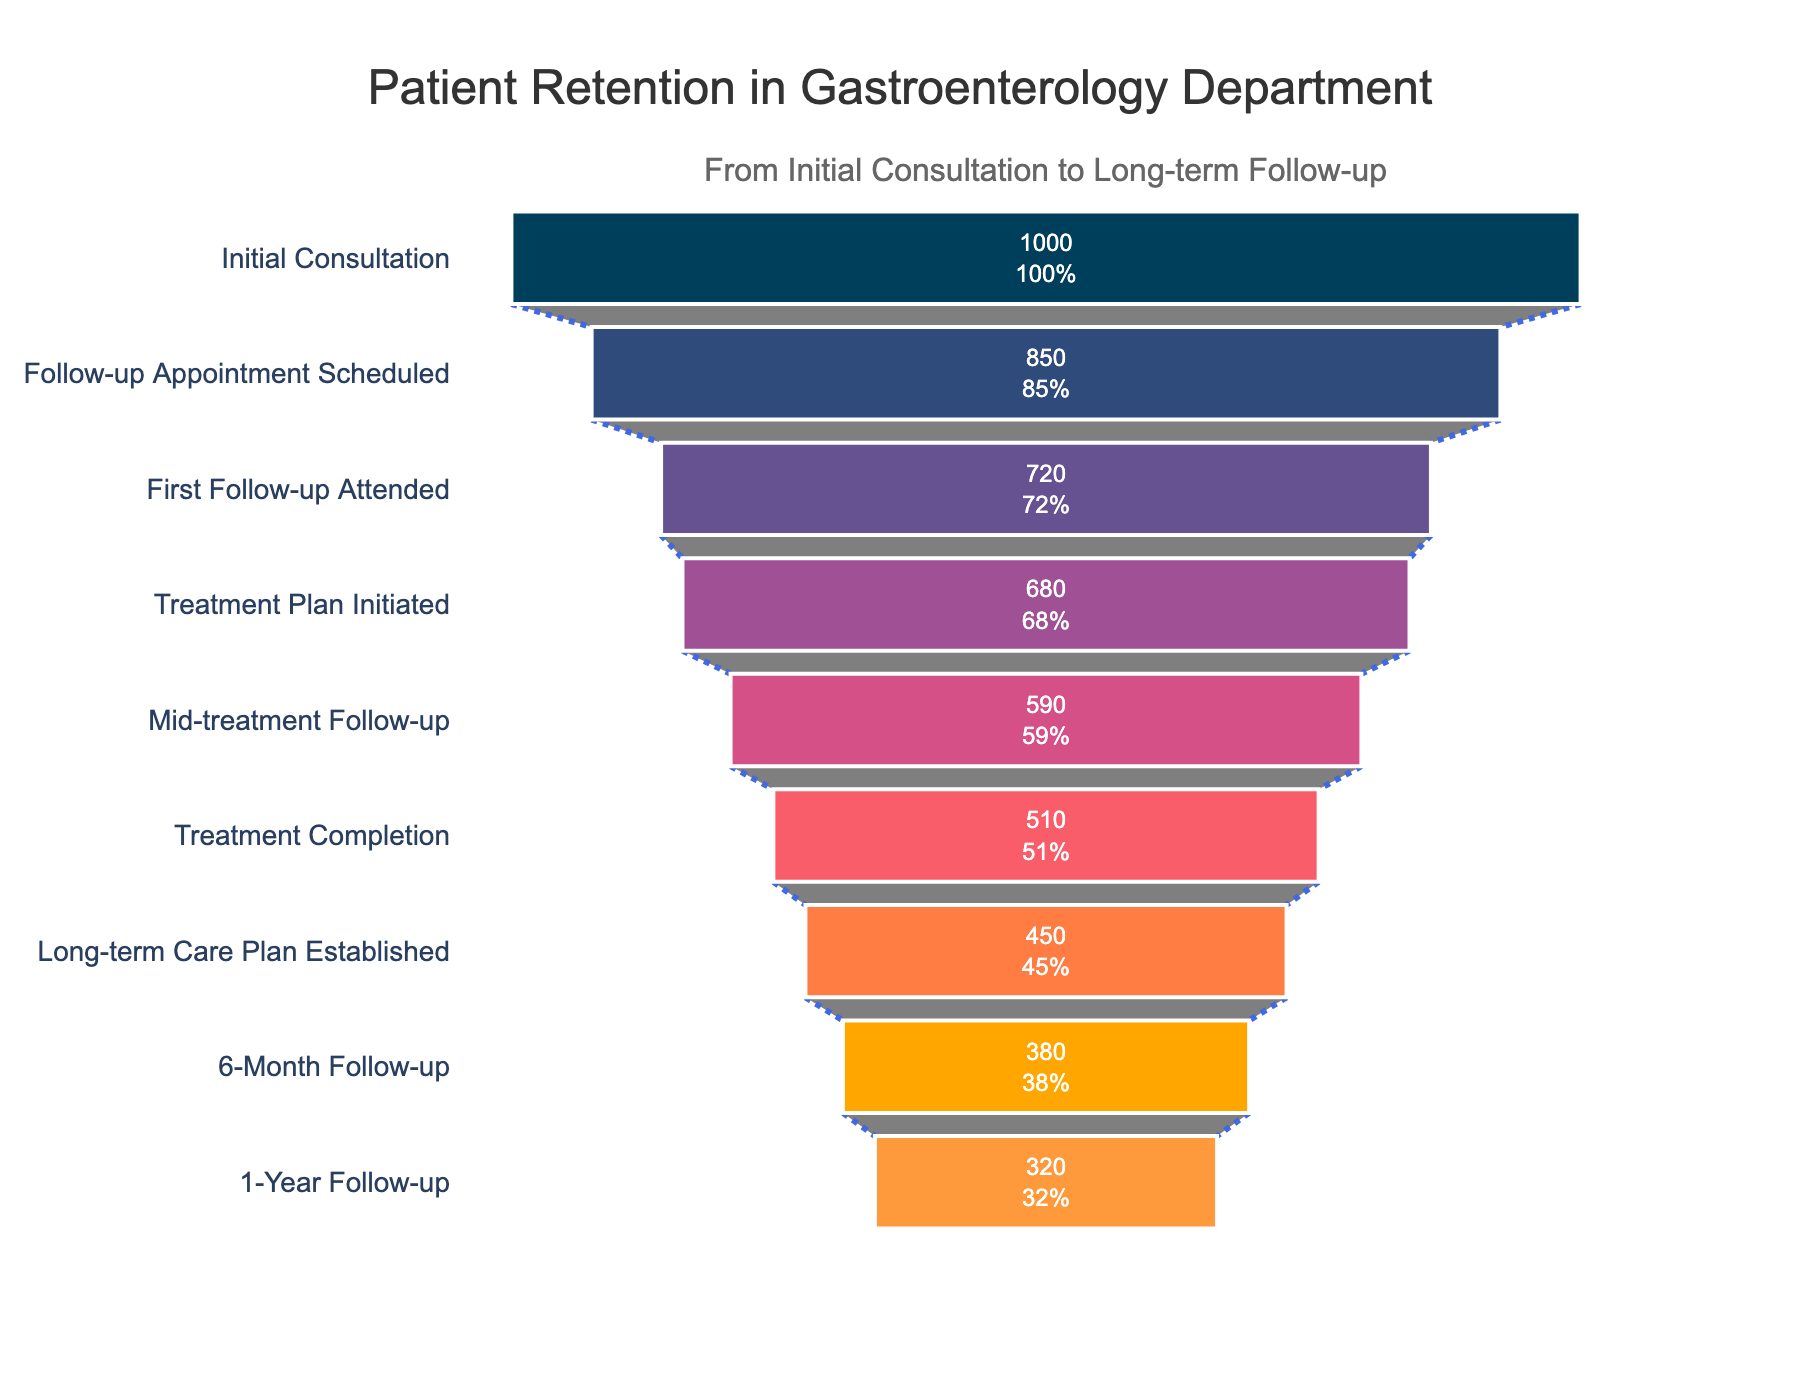What is the total number of patients at the Initial Consultation stage? According to the figure, the number of patients at the Initial Consultation stage is displayed at the top of the funnel chart.
Answer: 1000 How many patients transitioned from the Initial Consultation to the Follow-up Appointment Scheduled? The number of patients at the Initial Consultation is 1000, and the number of patients at the Follow-up Appointment Scheduled stage is 850. To find the number of patients who transitioned, subtract 850 from 1000.
Answer: 150 What percentage of patients attended the First Follow-up Appointment out of those scheduled? To find the percentage, divide the number of patients who attended the First Follow-up Appointment (720) by the number who had the Follow-up Appointment Scheduled (850) and multiply by 100. 720 / 850 * 100 = 84.71%
Answer: 84.71% Which stage has the largest drop in the number of patients? By examining the differences between consecutive stages, the largest drop can be identified. The difference between Treatment Plan Initiated (680) and Mid-treatment Follow-up (590) is 90, which is greater than drops in other stages.
Answer: Treatment Plan Initiated to Mid-treatment Follow-up How many patients fail to create a long-term care plan after Treatment Completion? The number of patients at the Treatment Completion stage is 510, and the number of patients who establish a Long-term Care Plan is 450. Subtract 450 from 510 to get the number of patients who fail to create a plan.
Answer: 60 What is the retention rate from Initial Consultation to 1-Year Follow-up? The retention rate is calculated by dividing the number of patients at the 1-Year Follow-up (320) by the number of patients at the Initial Consultation (1000) and multiplying by 100. 320 / 1000 * 100 = 32%
Answer: 32% Compare the percentage drop between the Mid-treatment Follow-up and Treatment Completion stages to the drop between Treatment Completion and Long-term Care Plan Established stages. Which is greater? Calculate the percentage drops: For Mid-treatment Follow-up to Treatment Completion, the drop is (590 - 510) / 590 * 100 = 13.56%. For Treatment Completion to Long-term Care Plan, the drop is (510 - 450) / 510 * 100 = 11.76%. Thus, the drop from Mid-treatment Follow-up to Treatment Completion is greater.
Answer: Mid-treatment Follow-up to Treatment Completion How many more patients reached the 6-Month Follow-up compared to the 1-Year Follow-up? Subtract the number of patients at the 1-Year Follow-up (320) from the number at the 6-Month Follow-up (380). 380 - 320 = 60
Answer: 60 What proportion of patients who initiated the Treatment Plan completed it? Divide the number of patients who completed the treatment (510) by the number who initiated the Treatment Plan (680) and multiply by 100 to get the percentage. 510 / 680 * 100 = 75%
Answer: 75% 